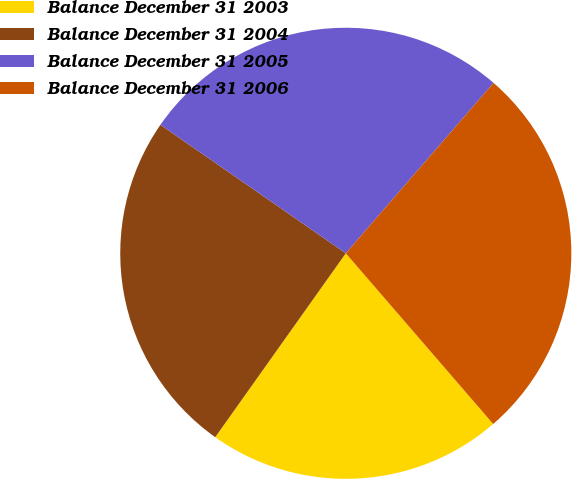Convert chart. <chart><loc_0><loc_0><loc_500><loc_500><pie_chart><fcel>Balance December 31 2003<fcel>Balance December 31 2004<fcel>Balance December 31 2005<fcel>Balance December 31 2006<nl><fcel>21.16%<fcel>24.82%<fcel>26.72%<fcel>27.29%<nl></chart> 